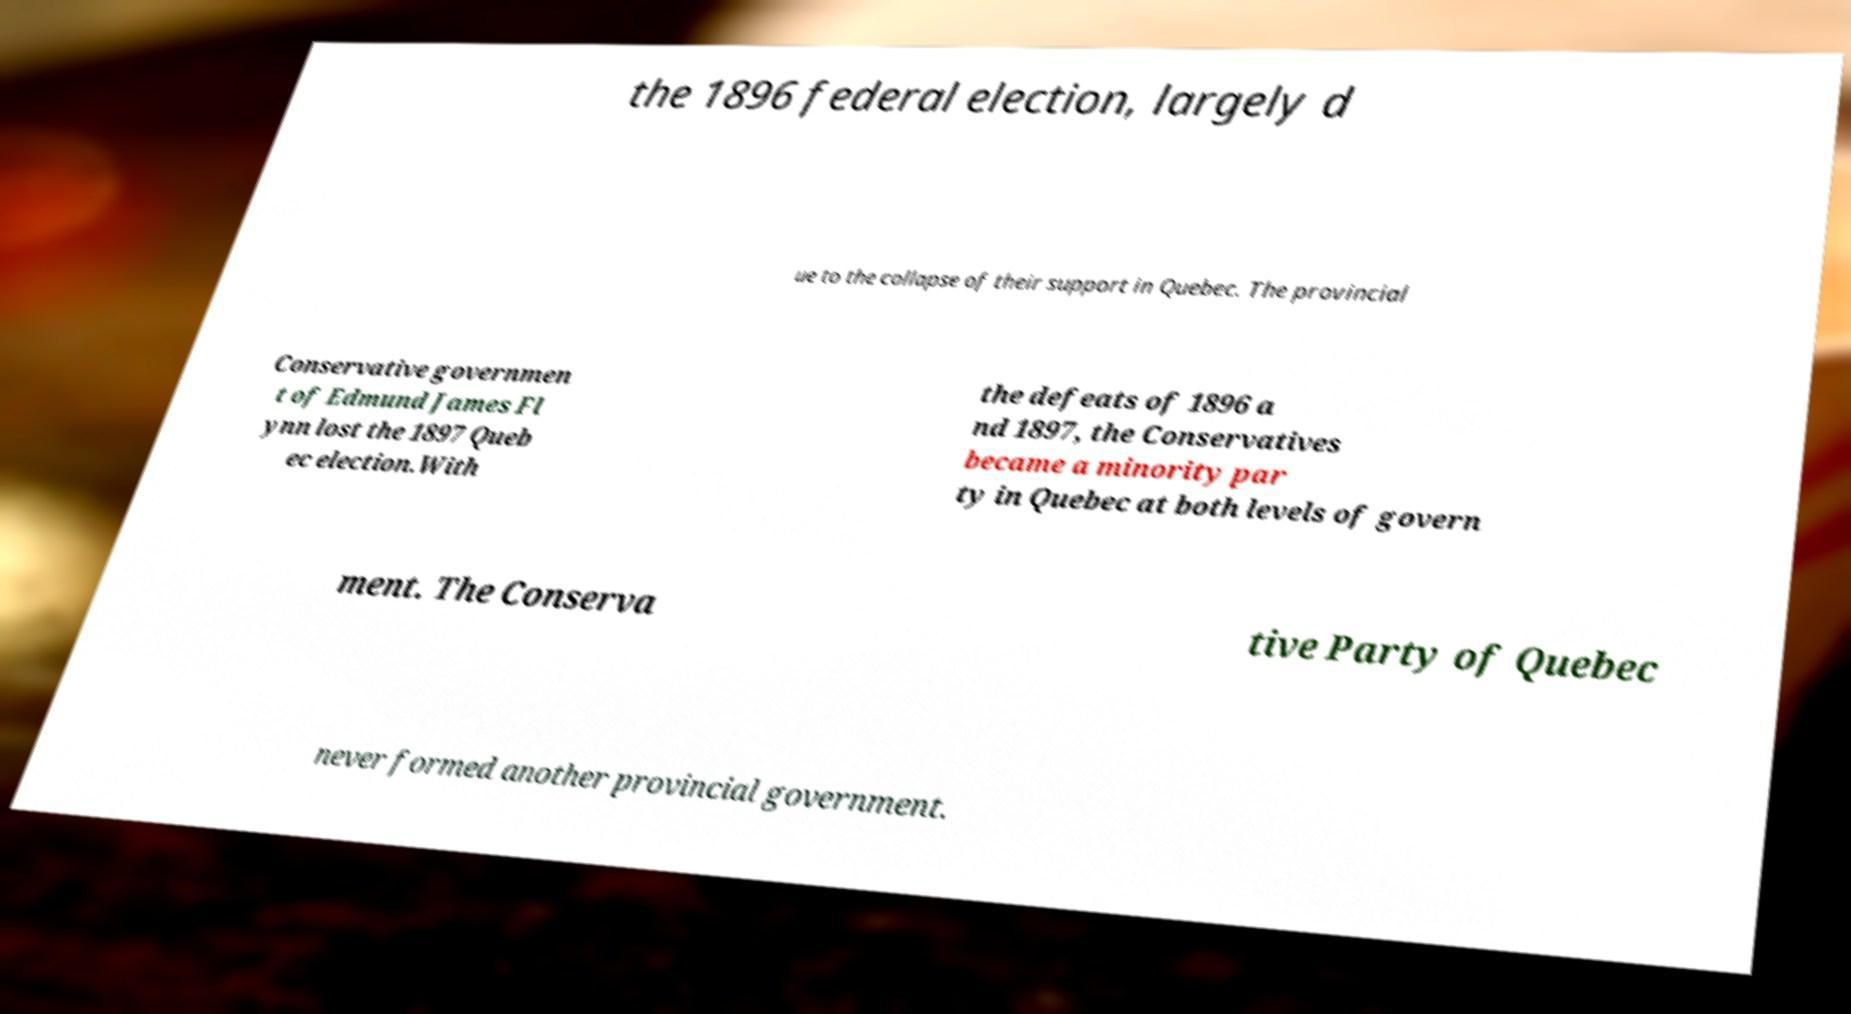Please identify and transcribe the text found in this image. the 1896 federal election, largely d ue to the collapse of their support in Quebec. The provincial Conservative governmen t of Edmund James Fl ynn lost the 1897 Queb ec election.With the defeats of 1896 a nd 1897, the Conservatives became a minority par ty in Quebec at both levels of govern ment. The Conserva tive Party of Quebec never formed another provincial government. 